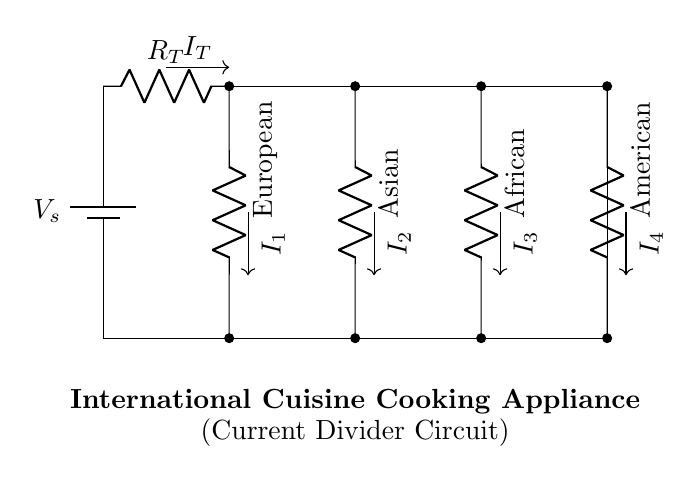What is the total resistance in this circuit? The total resistance is represented as \( R_T \) in the circuit diagram, which is the combined resistance of the heating elements in parallel.
Answer: R_T What are the different regions represented in this circuit? The circuit diagram has four distinct heating elements labeled as European, Asian, African, and American, each representing different culinary traditions.
Answer: European, Asian, African, American What is the total current flowing into the circuit? The current entering the circuit from the power source is denoted as \( I_T \), which is the total current supplied to the entire setup before it divides at the parallel branches.
Answer: I_T How does the current divide among the heating elements? In a current divider, the total current divides inversely proportional to the resistance of each parallel branch; smaller resistances draw more current, and larger resistances draw less.
Answer: Inversely proportional If the resistance of the European heating element is half that of the American heating element, what can be inferred about the currents through them? Since the European element has half the resistance of the American element, it will have a current approximately double that of the American heating element according to the current divider rule.
Answer: European current is double Which element contributes the least current in this configuration? The heating element with the highest resistance among parallel branches will contribute the least current. This is inferred from the current divider principle stated earlier.
Answer: American What is the primary purpose of this current divider circuit? The primary purpose is to provide different heating profiles for various international cuisines by allowing distinct power levels to multiple heating elements simultaneously.
Answer: Provide distinct power levels 